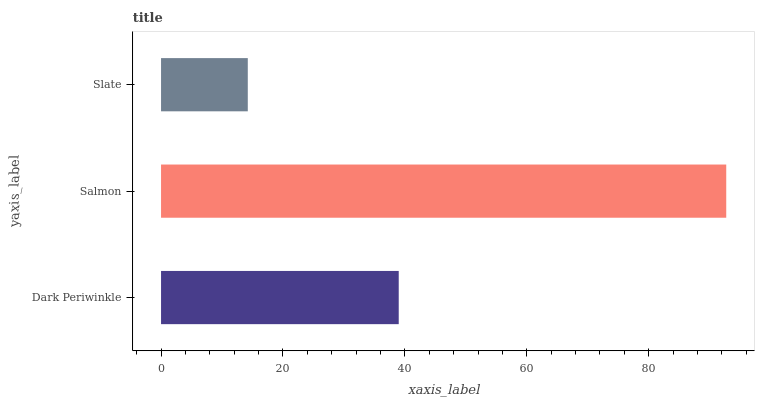Is Slate the minimum?
Answer yes or no. Yes. Is Salmon the maximum?
Answer yes or no. Yes. Is Salmon the minimum?
Answer yes or no. No. Is Slate the maximum?
Answer yes or no. No. Is Salmon greater than Slate?
Answer yes or no. Yes. Is Slate less than Salmon?
Answer yes or no. Yes. Is Slate greater than Salmon?
Answer yes or no. No. Is Salmon less than Slate?
Answer yes or no. No. Is Dark Periwinkle the high median?
Answer yes or no. Yes. Is Dark Periwinkle the low median?
Answer yes or no. Yes. Is Salmon the high median?
Answer yes or no. No. Is Slate the low median?
Answer yes or no. No. 